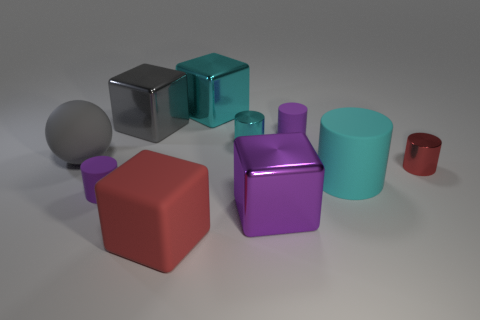There is a small red thing; how many big purple metallic blocks are right of it?
Ensure brevity in your answer.  0. What material is the object that is the same color as the big matte block?
Provide a succinct answer. Metal. Are there any large red objects of the same shape as the gray metal object?
Give a very brief answer. Yes. Is the big cyan cylinder behind the large red thing made of the same material as the tiny object that is on the left side of the big red matte block?
Your answer should be compact. Yes. There is a cyan cylinder that is in front of the shiny thing that is right of the big purple shiny object behind the large red object; what size is it?
Your answer should be very brief. Large. What is the material of the red cube that is the same size as the ball?
Your answer should be compact. Rubber. Are there any shiny blocks that have the same size as the cyan matte cylinder?
Provide a short and direct response. Yes. Is the gray metallic object the same shape as the small cyan thing?
Your answer should be very brief. No. Are there any gray things that are in front of the cyan metal object that is in front of the matte cylinder behind the red cylinder?
Make the answer very short. Yes. What number of other objects are there of the same color as the rubber sphere?
Offer a very short reply. 1. 